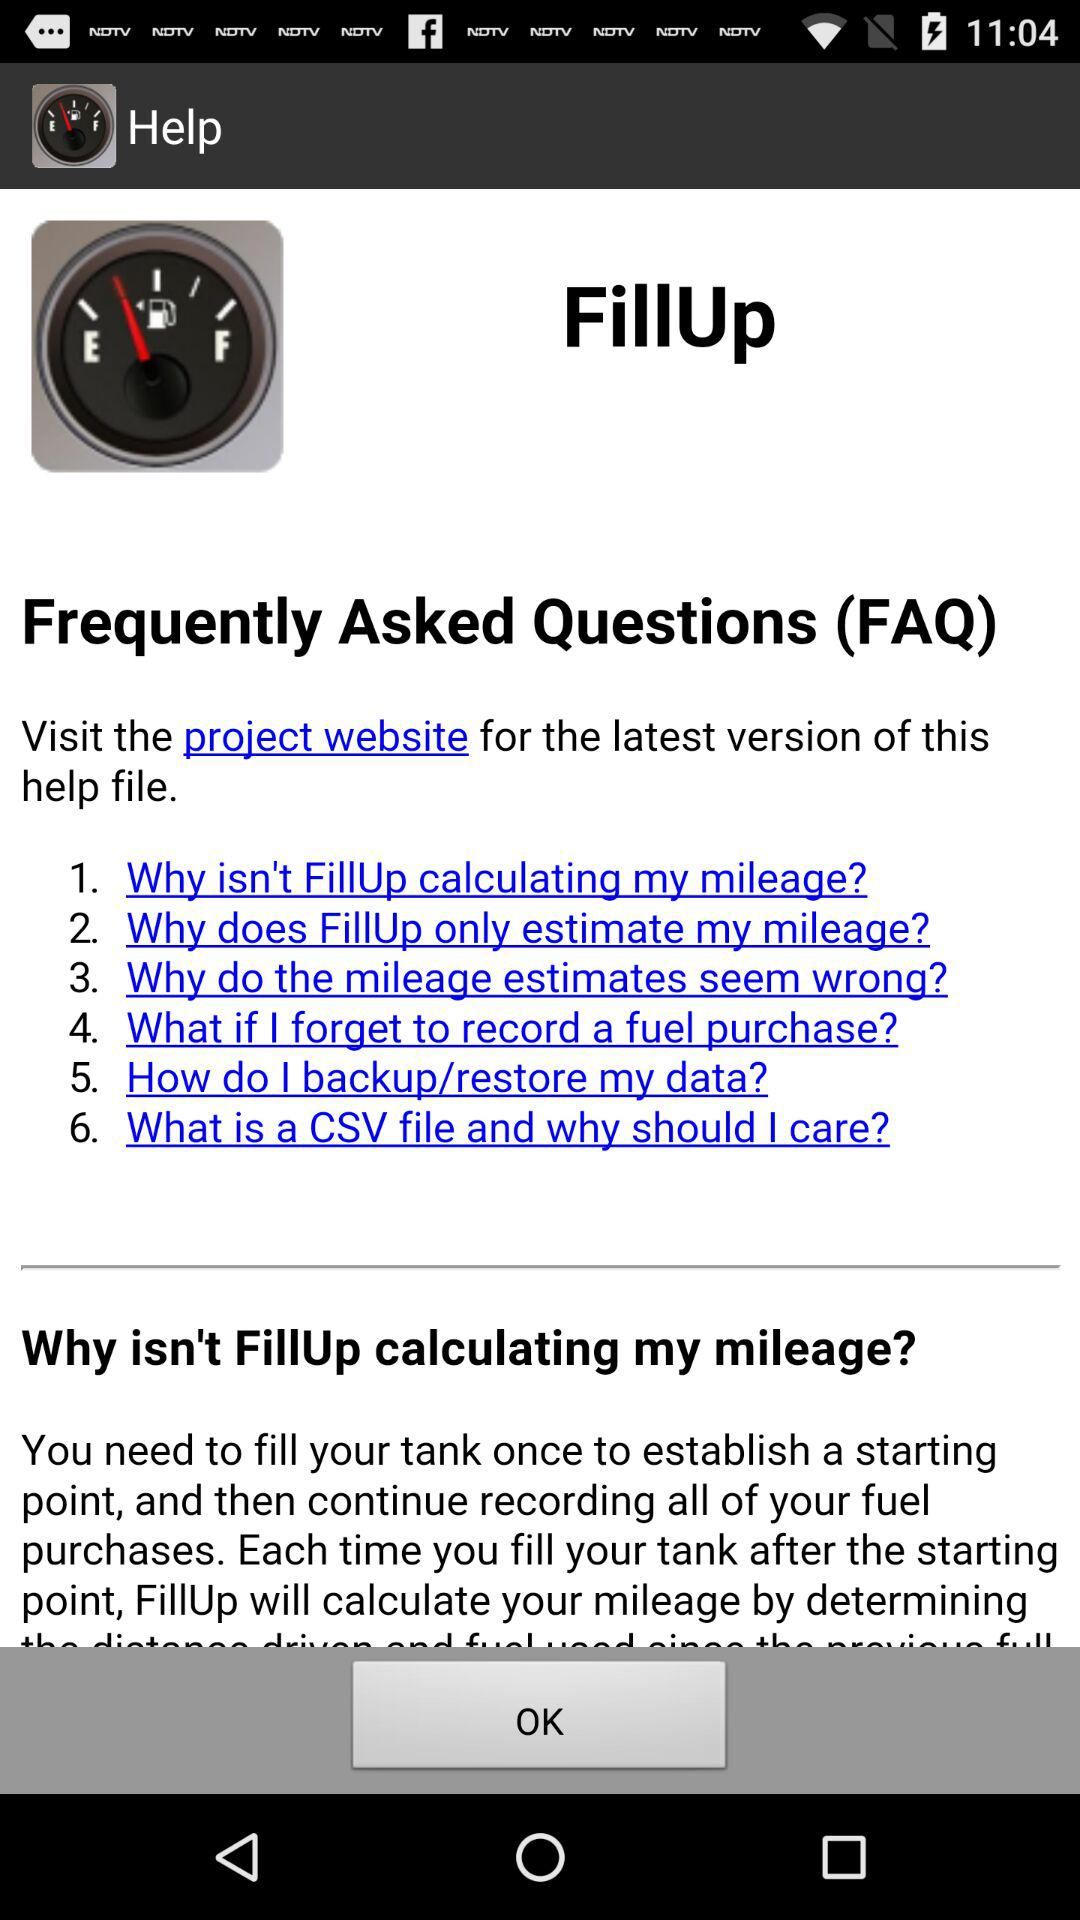What are the frequently asked questions on FillUp? The frequently asked questions on FillUp are "Why isn't FillUp calculating my mileage?", "Why does FillUp only estimate my mileage?", "Why do the mileage estimates seem wrong?", "What if I forget to record a fuel purchase?", "How do I backup/restore my data?" and "What is a CSV file and why should I care?". 